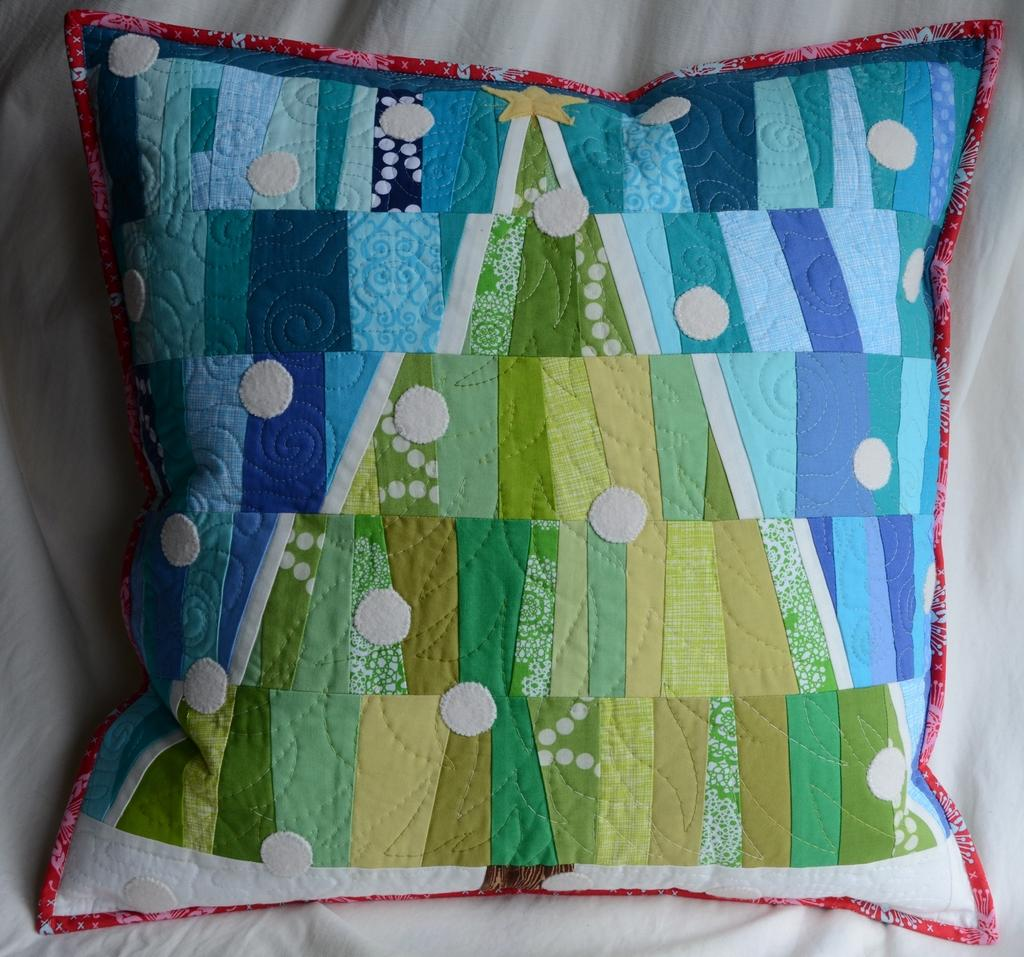What object is present in the image? There is a pillow in the image. What is the pillow placed on? The pillow is on a cloth. What color is the background of the image? The background of the image is white in color. How many sheep can be seen in the image? There are no sheep present in the image. 